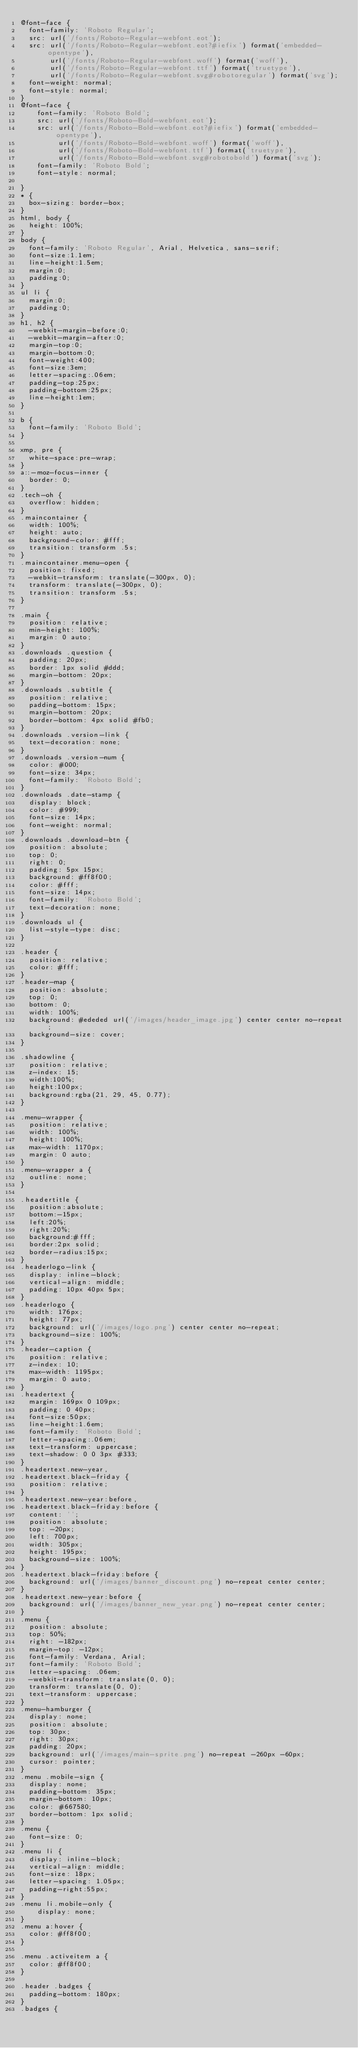Convert code to text. <code><loc_0><loc_0><loc_500><loc_500><_CSS_>@font-face {
  font-family: 'Roboto Regular';
  src: url('/fonts/Roboto-Regular-webfont.eot');
  src: url('/fonts/Roboto-Regular-webfont.eot?#iefix') format('embedded-opentype'),
       url('/fonts/Roboto-Regular-webfont.woff') format('woff'),
       url('/fonts/Roboto-Regular-webfont.ttf') format('truetype'),
       url('/fonts/Roboto-Regular-webfont.svg#robotoregular') format('svg');
  font-weight: normal;
  font-style: normal;
}
@font-face {
    font-family: 'Roboto Bold';
    src: url('/fonts/Roboto-Bold-webfont.eot');
    src: url('/fonts/Roboto-Bold-webfont.eot?#iefix') format('embedded-opentype'),
         url('/fonts/Roboto-Bold-webfont.woff') format('woff'),
         url('/fonts/Roboto-Bold-webfont.ttf') format('truetype'),
         url('/fonts/Roboto-Bold-webfont.svg#robotobold') format('svg');
    font-family: 'Roboto Bold';
    font-style: normal;

}
* {
  box-sizing: border-box;
}
html, body {
  height: 100%;
}
body {
  font-family: 'Roboto Regular', Arial, Helvetica, sans-serif;
  font-size:1.1em;
  line-height:1.5em;
  margin:0;
  padding:0;
}
ul li {
  margin:0;
  padding:0;
}
h1, h2 {
  -webkit-margin-before:0;
  -webkit-margin-after:0;
  margin-top:0;
  margin-bottom:0;
  font-weight:400;
  font-size:3em;
  letter-spacing:.06em;
  padding-top:25px;
  padding-bottom:25px;
  line-height:1em;
}

b {
  font-family: 'Roboto Bold';
}

xmp, pre {
  white-space:pre-wrap;
}
a::-moz-focus-inner {
  border: 0;
}
.tech-oh {
  overflow: hidden;
}
.maincontainer {
  width: 100%;
  height: auto;
  background-color: #fff;
  transition: transform .5s;
}
.maincontainer.menu-open {
  position: fixed;
  -webkit-transform: translate(-300px, 0);
  transform: translate(-300px, 0);
  transition: transform .5s;
}

.main {
  position: relative;
  min-height: 100%;
  margin: 0 auto;
}
.downloads .question {
  padding: 20px;
  border: 1px solid #ddd;
  margin-bottom: 20px;
}
.downloads .subtitle {
  position: relative;
  padding-bottom: 15px;
  margin-bottom: 20px;
  border-bottom: 4px solid #fb0;
}
.downloads .version-link {
  text-decoration: none;
}
.downloads .version-num {
  color: #000;
  font-size: 34px;
  font-family: 'Roboto Bold';
}
.downloads .date-stamp {
  display: block;
  color: #999;
  font-size: 14px;
  font-weight: normal;
}
.downloads .download-btn {
  position: absolute;
  top: 0;
  right: 0;
  padding: 5px 15px;
  background: #ff8f00;
  color: #fff;
  font-size: 14px;
  font-family: 'Roboto Bold';
  text-decoration: none;
}
.downloads ul {
  list-style-type: disc;
}

.header {
  position: relative;
  color: #fff;
}
.header-map {
  position: absolute;
  top: 0;
  bottom: 0;
  width: 100%;
  background: #ededed url('/images/header_image.jpg') center center no-repeat;
  background-size: cover;
}

.shadowline {
  position: relative;
  z-index: 15;
  width:100%;
  height:100px;
  background:rgba(21, 29, 45, 0.77);
}

.menu-wrapper {
  position: relative;
  width: 100%;
  height: 100%;
  max-width: 1170px;
  margin: 0 auto;
}
.menu-wrapper a {
  outline: none;
}

.headertitle {
  position:absolute;
  bottom:-15px;
  left:20%;
  right:20%;
  background:#fff;
  border:2px solid;
  border-radius:15px;
}
.headerlogo-link {
  display: inline-block;
  vertical-align: middle;
  padding: 10px 40px 5px;
}
.headerlogo {
  width: 176px;
  height: 77px;
  background: url('/images/logo.png') center center no-repeat;
  background-size: 100%;
}
.header-caption {
  position: relative;
  z-index: 10;
  max-width: 1195px;
  margin: 0 auto;
}
.headertext {
  margin: 169px 0 109px;
  padding: 0 40px;
  font-size:50px;
  line-height:1.6em;
  font-family: 'Roboto Bold';
  letter-spacing:.06em;
  text-transform: uppercase;
  text-shadow: 0 0 3px #333;
}
.headertext.new-year,
.headertext.black-friday {
  position: relative;
}
.headertext.new-year:before,
.headertext.black-friday:before {
  content: '';
  position: absolute;
  top: -20px;
  left: 700px;
  width: 305px;
  height: 195px;
  background-size: 100%;
}
.headertext.black-friday:before {
  background: url('/images/banner_discount.png') no-repeat center center;
}
.headertext.new-year:before {
  background: url('/images/banner_new_year.png') no-repeat center center;
}
.menu {
  position: absolute;
  top: 50%;
  right: -182px;
  margin-top: -12px;
  font-family: Verdana, Arial;
  font-family: 'Roboto Bold';
  letter-spacing: .06em;
  -webkit-transform: translate(0, 0);
  transform: translate(0, 0);
  text-transform: uppercase;
}
.menu-hamburger {
  display: none;
  position: absolute;
  top: 30px;
  right: 30px;
  padding: 20px;
  background: url('/images/main-sprite.png') no-repeat -260px -60px;
  cursor: pointer;
}
.menu .mobile-sign {
  display: none;
  padding-bottom: 35px;
  margin-bottom: 10px;
  color: #667580;
  border-bottom: 1px solid;
}
.menu {
  font-size: 0;
}
.menu li {
  display: inline-block;
  vertical-align: middle;
  font-size: 18px;
  letter-spacing: 1.05px;
  padding-right:55px;
}
.menu li.mobile-only {
	display: none;
}
.menu a:hover {
  color: #ff8f00;
}

.menu .activeitem a {
  color: #ff8f00;
}

.header .badges {
  padding-bottom: 180px;
}
.badges {</code> 